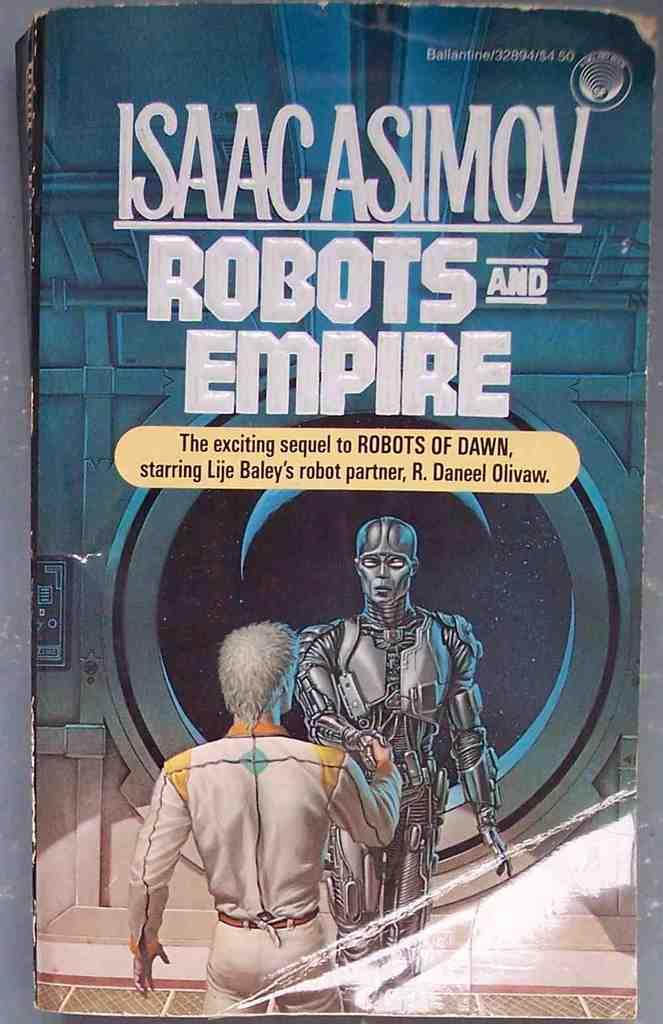<image>
Provide a brief description of the given image. A copy of Isaac Asimov's Robots and Empire. 